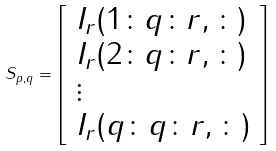Convert formula to latex. <formula><loc_0><loc_0><loc_500><loc_500>S _ { p , q } = { \left [ \begin{array} { l } { I _ { r } ( 1 \colon q \colon r , \colon ) } \\ { I _ { r } ( 2 \colon q \colon r , \colon ) } \\ { \vdots } \\ { I _ { r } ( q \colon q \colon r , \colon ) } \end{array} \right ] }</formula> 